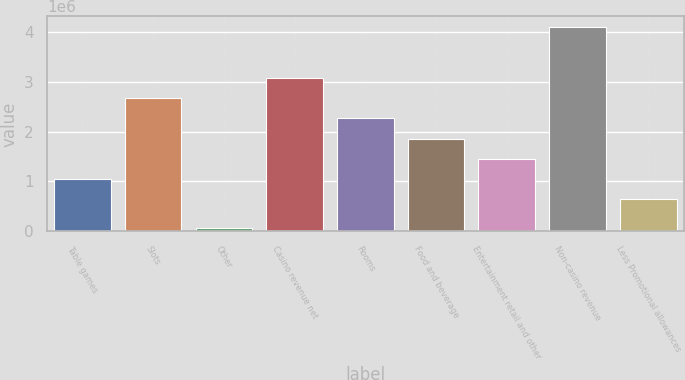<chart> <loc_0><loc_0><loc_500><loc_500><bar_chart><fcel>Table games<fcel>Slots<fcel>Other<fcel>Casino revenue net<fcel>Rooms<fcel>Food and beverage<fcel>Entertainment retail and other<fcel>Non-casino revenue<fcel>Less Promotional allowances<nl><fcel>1.05323e+06<fcel>2.6678e+06<fcel>66257<fcel>3.07144e+06<fcel>2.26416e+06<fcel>1.86051e+06<fcel>1.45687e+06<fcel>4.10266e+06<fcel>649592<nl></chart> 